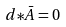Convert formula to latex. <formula><loc_0><loc_0><loc_500><loc_500>d { * \bar { A } } = 0</formula> 